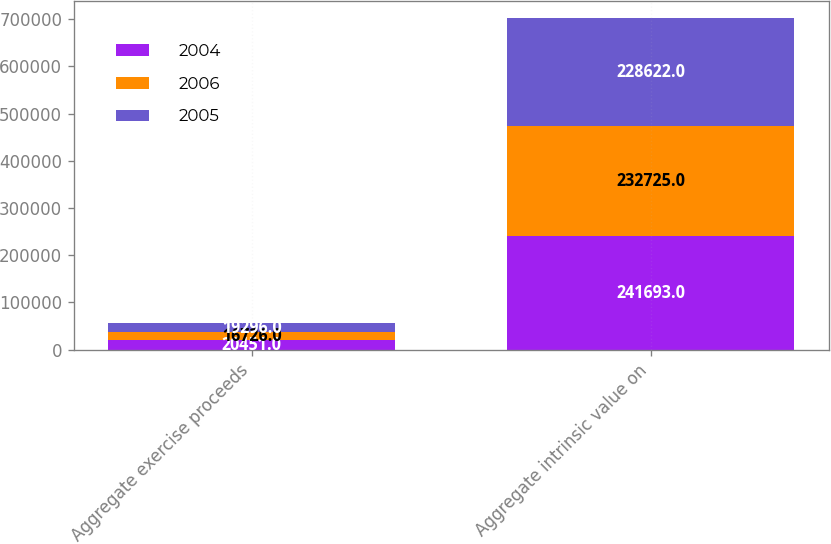Convert chart. <chart><loc_0><loc_0><loc_500><loc_500><stacked_bar_chart><ecel><fcel>Aggregate exercise proceeds<fcel>Aggregate intrinsic value on<nl><fcel>2004<fcel>20451<fcel>241693<nl><fcel>2006<fcel>16726<fcel>232725<nl><fcel>2005<fcel>19296<fcel>228622<nl></chart> 